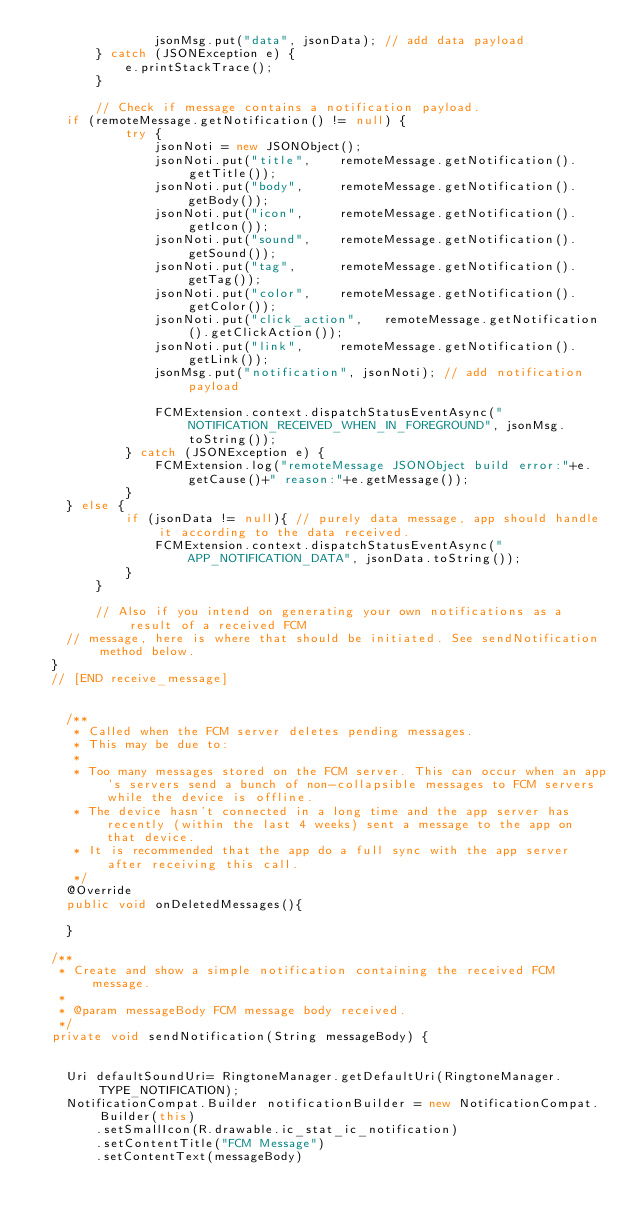Convert code to text. <code><loc_0><loc_0><loc_500><loc_500><_Java_>                jsonMsg.put("data", jsonData); // add data payload
        } catch (JSONException e) {
            e.printStackTrace();
        }

        // Check if message contains a notification payload.
		if (remoteMessage.getNotification() != null) {
            try {
                jsonNoti = new JSONObject();
                jsonNoti.put("title",    remoteMessage.getNotification().getTitle());
                jsonNoti.put("body",     remoteMessage.getNotification().getBody());
                jsonNoti.put("icon",     remoteMessage.getNotification().getIcon());
                jsonNoti.put("sound",    remoteMessage.getNotification().getSound());
                jsonNoti.put("tag",      remoteMessage.getNotification().getTag());
                jsonNoti.put("color",    remoteMessage.getNotification().getColor());
                jsonNoti.put("click_action",   remoteMessage.getNotification().getClickAction());
                jsonNoti.put("link",     remoteMessage.getNotification().getLink());
                jsonMsg.put("notification", jsonNoti); // add notification payload

                FCMExtension.context.dispatchStatusEventAsync("NOTIFICATION_RECEIVED_WHEN_IN_FOREGROUND", jsonMsg.toString());
            } catch (JSONException e) {
                FCMExtension.log("remoteMessage JSONObject build error:"+e.getCause()+" reason:"+e.getMessage());
            }
		} else {
            if (jsonData != null){ // purely data message, app should handle it according to the data received.
                FCMExtension.context.dispatchStatusEventAsync("APP_NOTIFICATION_DATA", jsonData.toString());
            }
        }

        // Also if you intend on generating your own notifications as a result of a received FCM
		// message, here is where that should be initiated. See sendNotification method below.
	}
	// [END receive_message]


    /**
     * Called when the FCM server deletes pending messages.
     * This may be due to:
     *
     * Too many messages stored on the FCM server. This can occur when an app's servers send a bunch of non-collapsible messages to FCM servers while the device is offline.
     * The device hasn't connected in a long time and the app server has recently (within the last 4 weeks) sent a message to the app on that device.
     * It is recommended that the app do a full sync with the app server after receiving this call.
     */
    @Override
    public void onDeletedMessages(){

    }

	/**
	 * Create and show a simple notification containing the received FCM message.
	 *
	 * @param messageBody FCM message body received.
	 */
	private void sendNotification(String messageBody) {


		Uri defaultSoundUri= RingtoneManager.getDefaultUri(RingtoneManager.TYPE_NOTIFICATION);
		NotificationCompat.Builder notificationBuilder = new NotificationCompat.Builder(this)
				.setSmallIcon(R.drawable.ic_stat_ic_notification)
				.setContentTitle("FCM Message")
				.setContentText(messageBody)</code> 